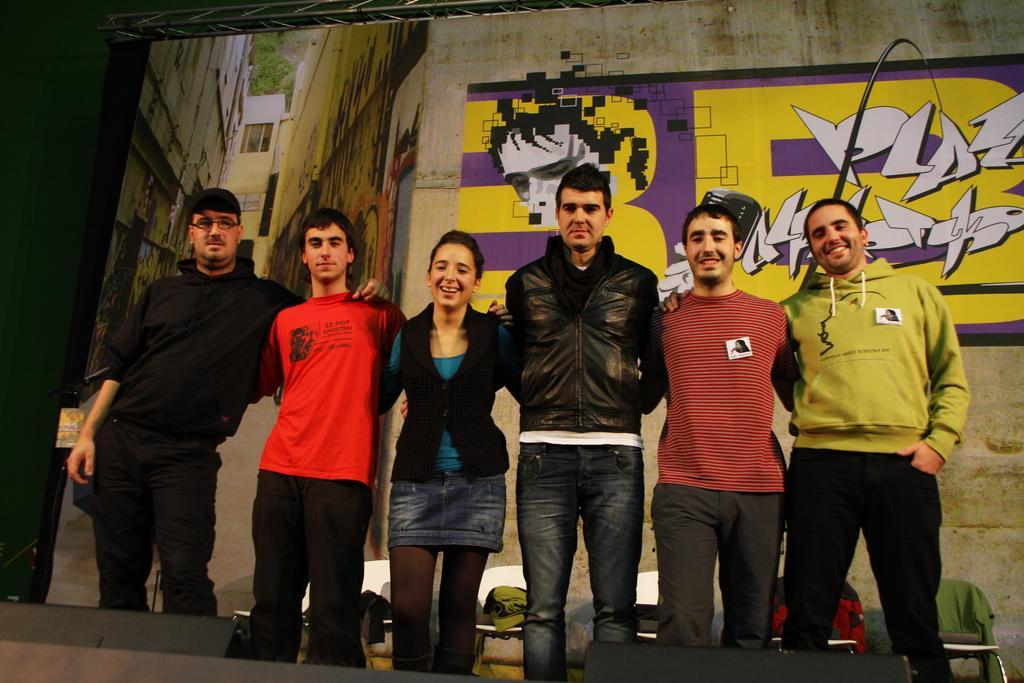Could you give a brief overview of what you see in this image? Here we can see few persons and they are smiling. There are chairs and clothes. In the background we can see a screen. On the screen we can see painting on the wall, buildings, and trees. 